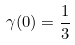<formula> <loc_0><loc_0><loc_500><loc_500>\gamma ( 0 ) = \frac { 1 } { 3 }</formula> 